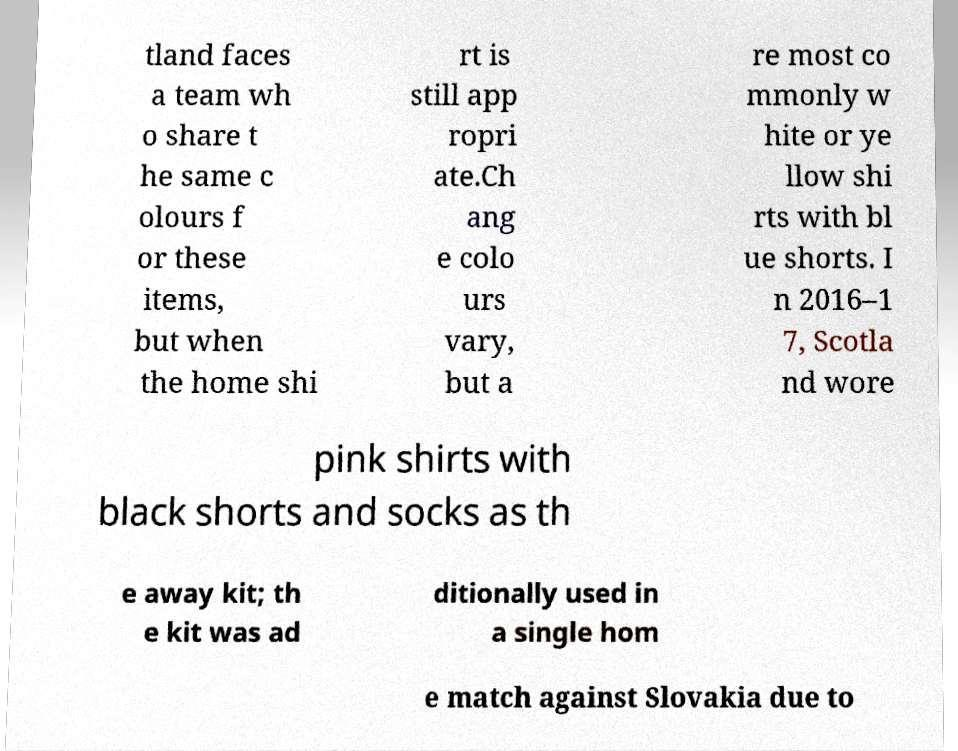Please read and relay the text visible in this image. What does it say? tland faces a team wh o share t he same c olours f or these items, but when the home shi rt is still app ropri ate.Ch ang e colo urs vary, but a re most co mmonly w hite or ye llow shi rts with bl ue shorts. I n 2016–1 7, Scotla nd wore pink shirts with black shorts and socks as th e away kit; th e kit was ad ditionally used in a single hom e match against Slovakia due to 